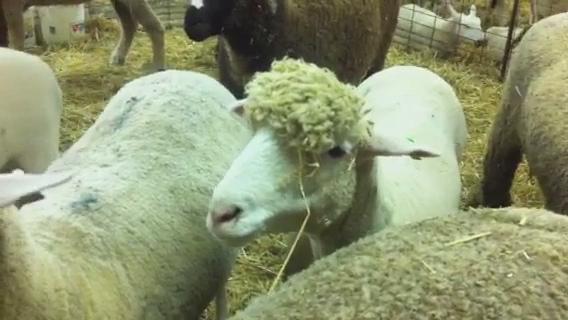How many sheep can you see?
Give a very brief answer. 8. How many girl are there in the image?
Give a very brief answer. 0. 